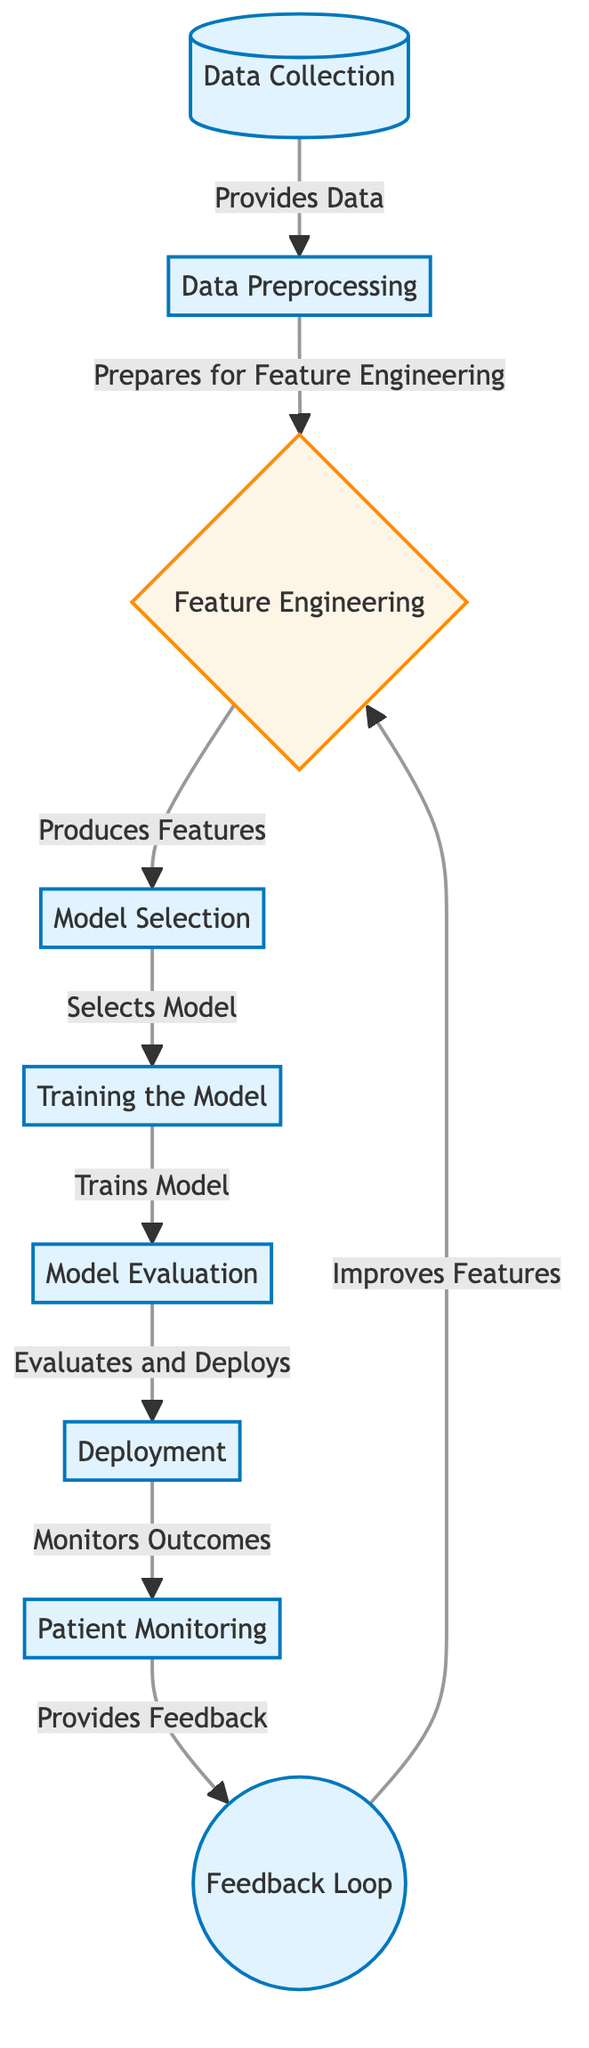What is the first step in the process? The first step in the process is "Data Collection," which is represented as the first node in the diagram. It provides the initial data necessary for all subsequent activities.
Answer: Data Collection How many total nodes are in the diagram? By counting all distinct steps and decisions represented in the diagram, there are a total of nine nodes that serve different purposes in the predictive analytics process.
Answer: Nine Which node follows "Model Evaluation"? According to the flow of the diagram, after "Model Evaluation," the next step is "Deployment," which is indicated by the directed arrow from one node to the next.
Answer: Deployment What provides feedback in the process? The "Patient Monitoring" node is responsible for providing feedback, as indicated by its connection to the "Feedback Loop" node in the diagram.
Answer: Patient Monitoring How does the feedback loop influence the process? The feedback loop influences the process by providing information back to the "Feature Engineering" decision node, which indicates that it helps in improving features for subsequent model iterations. This creates a cyclic improvement mechanism in the model.
Answer: Improves Features What role does "Feature Engineering" play in this diagram? "Feature Engineering" serves as a decision node that produces features that are subsequently used for model selection. It is crucial for identifying relevant data components that can enhance model performance.
Answer: Produces Features Identify the connection between "Training the Model" and "Model Evaluation." There is a direct relationship where "Training the Model" leads to "Model Evaluation." After training, the model's performance is thoroughly evaluated to determine its effectiveness before deployment.
Answer: Evaluates and Deploys What is the last step in the predictive analytics process? The last step in the diagram is "Patient Monitoring," where outcomes are monitored post-deployment to assess the model’s performance and impact on high-risk patients.
Answer: Patient Monitoring 